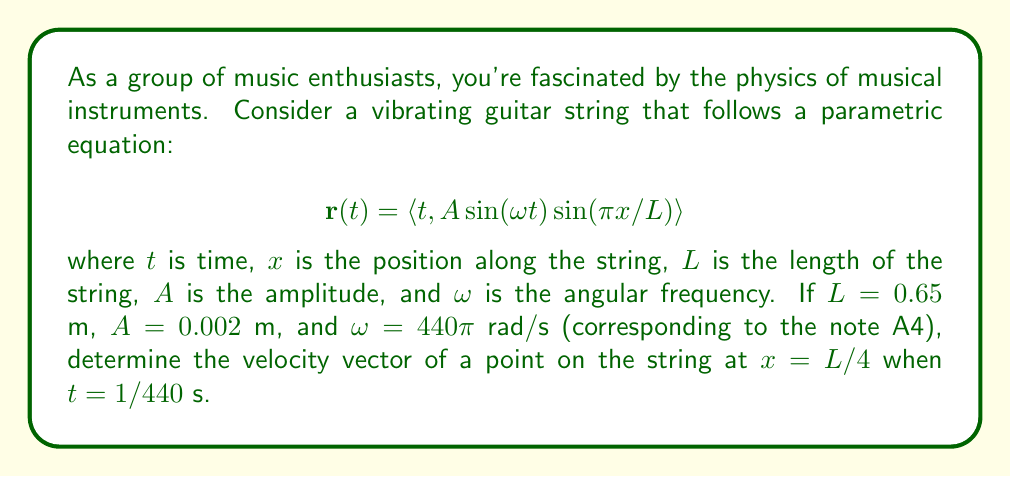Solve this math problem. To solve this problem, we need to follow these steps:

1) First, we need to understand what the parametric equation represents. The x-component is simply $t$, while the y-component describes the vertical displacement of the string.

2) To find the velocity vector, we need to differentiate $\mathbf{r}(t)$ with respect to $t$:

   $$\mathbf{v}(t) = \frac{d\mathbf{r}}{dt} = \left\langle \frac{dx}{dt}, \frac{dy}{dt} \right\rangle$$

3) Differentiating each component:
   
   $$\frac{dx}{dt} = 1$$
   
   $$\begin{align}
   \frac{dy}{dt} &= A\omega \cos(\omega t) \sin(\pi x/L) + A \sin(\omega t) \sin(\pi x/L) \cdot 0 \\
   &= A\omega \cos(\omega t) \sin(\pi x/L)
   \end{align}$$

4) Therefore, the velocity vector is:

   $$\mathbf{v}(t) = \left\langle 1, A\omega \cos(\omega t) \sin(\pi x/L) \right\rangle$$

5) Now, let's substitute the given values:
   $L = 0.65$ m
   $A = 0.002$ m
   $\omega = 440\pi$ rad/s
   $x = L/4 = 0.65/4 = 0.1625$ m
   $t = 1/440$ s

6) Calculating $\sin(\pi x/L)$:
   
   $$\sin(\pi x/L) = \sin(\pi \cdot 0.1625 / 0.65) = \sin(\pi/4) = \frac{\sqrt{2}}{2}$$

7) Calculating $\cos(\omega t)$:
   
   $$\cos(\omega t) = \cos(440\pi \cdot 1/440) = \cos(\pi) = -1$$

8) Now we can substitute these values into our velocity vector:

   $$\mathbf{v}(1/440) = \left\langle 1, 0.002 \cdot 440\pi \cdot (-1) \cdot \frac{\sqrt{2}}{2} \right\rangle$$

9) Simplifying:

   $$\mathbf{v}(1/440) = \left\langle 1, -\sqrt{2}\pi \right\rangle$$
Answer: The velocity vector of a point on the string at $x = L/4$ when $t = 1/440$ s is:

$$\mathbf{v}(1/440) = \left\langle 1, -\sqrt{2}\pi \right\rangle \text{ m/s}$$ 